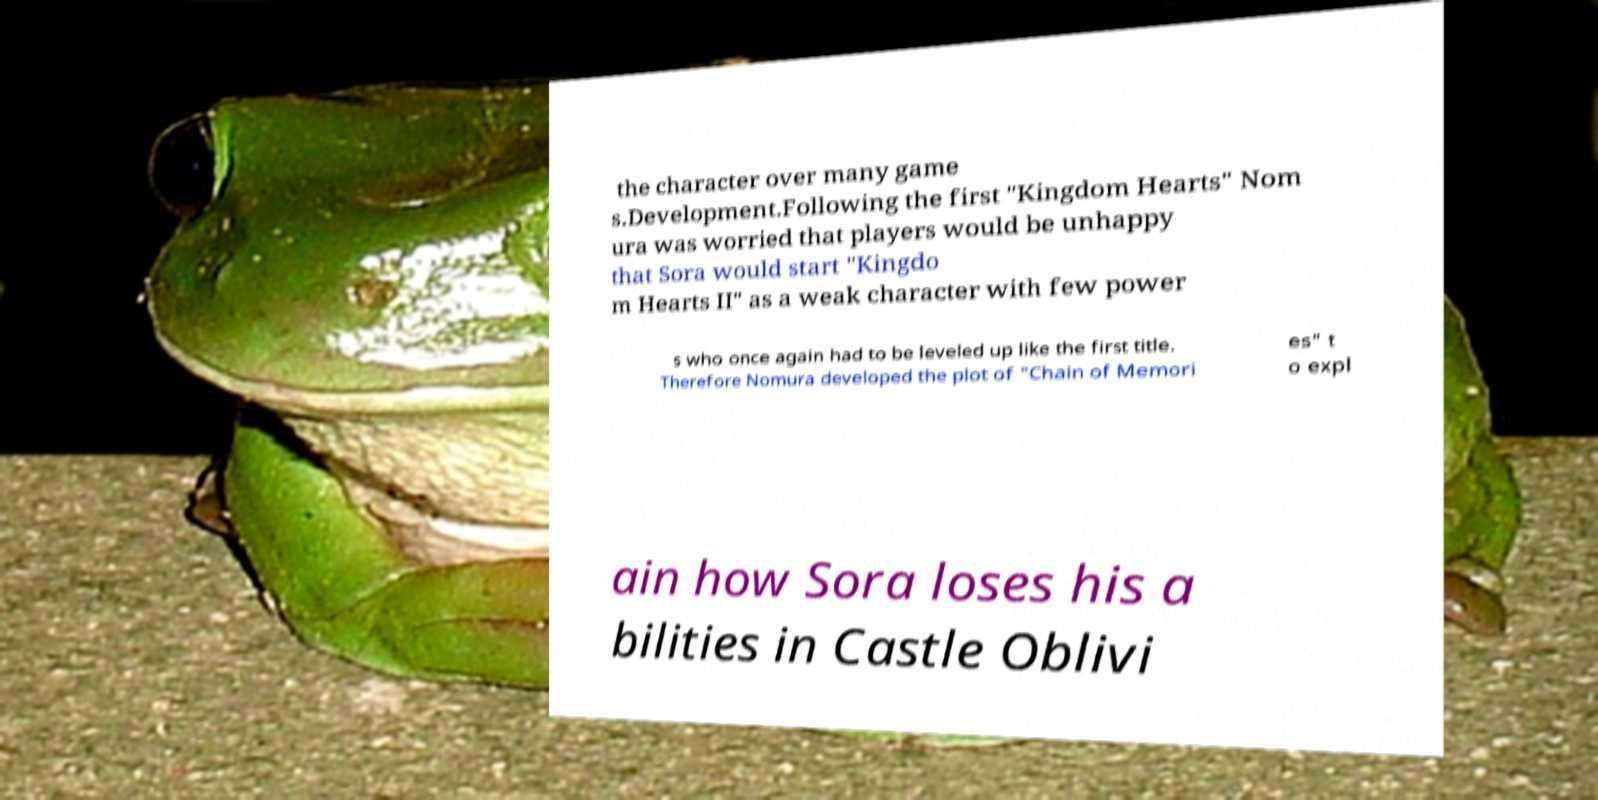What messages or text are displayed in this image? I need them in a readable, typed format. the character over many game s.Development.Following the first "Kingdom Hearts" Nom ura was worried that players would be unhappy that Sora would start "Kingdo m Hearts II" as a weak character with few power s who once again had to be leveled up like the first title. Therefore Nomura developed the plot of "Chain of Memori es" t o expl ain how Sora loses his a bilities in Castle Oblivi 